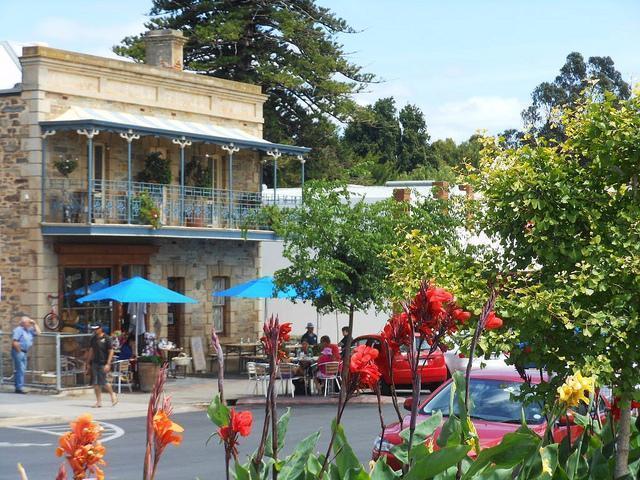Where does this scene take place?
Select the accurate response from the four choices given to answer the question.
Options: Cafe, house, condo, club. Cafe. 